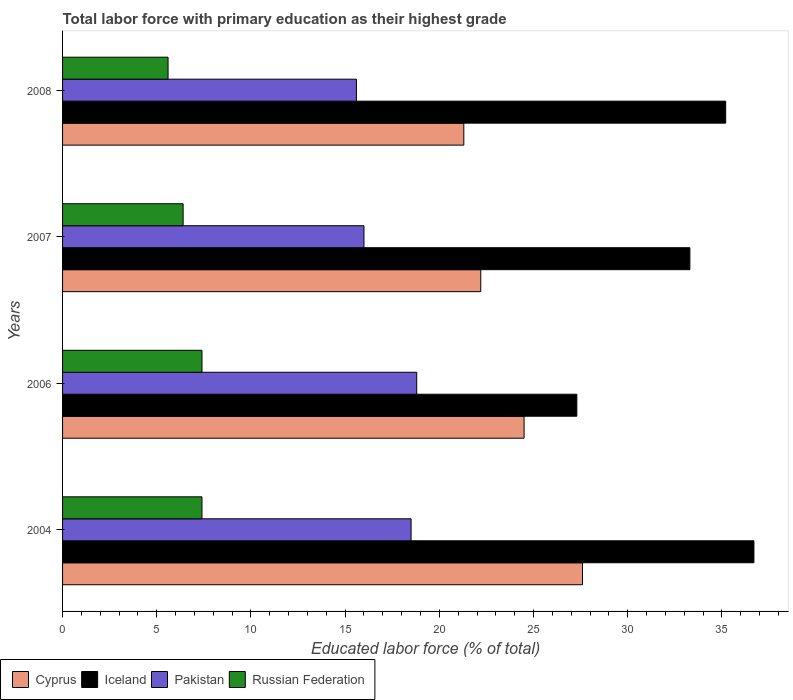How many groups of bars are there?
Your answer should be very brief. 4. Are the number of bars per tick equal to the number of legend labels?
Provide a short and direct response. Yes. Are the number of bars on each tick of the Y-axis equal?
Keep it short and to the point. Yes. What is the label of the 2nd group of bars from the top?
Give a very brief answer. 2007. What is the percentage of total labor force with primary education in Pakistan in 2007?
Make the answer very short. 16. Across all years, what is the maximum percentage of total labor force with primary education in Iceland?
Provide a succinct answer. 36.7. Across all years, what is the minimum percentage of total labor force with primary education in Cyprus?
Provide a succinct answer. 21.3. In which year was the percentage of total labor force with primary education in Cyprus maximum?
Provide a short and direct response. 2004. In which year was the percentage of total labor force with primary education in Cyprus minimum?
Give a very brief answer. 2008. What is the total percentage of total labor force with primary education in Pakistan in the graph?
Your answer should be very brief. 68.9. What is the difference between the percentage of total labor force with primary education in Russian Federation in 2004 and that in 2006?
Make the answer very short. 0. What is the difference between the percentage of total labor force with primary education in Pakistan in 2004 and the percentage of total labor force with primary education in Russian Federation in 2007?
Ensure brevity in your answer.  12.1. What is the average percentage of total labor force with primary education in Pakistan per year?
Offer a very short reply. 17.22. In the year 2007, what is the difference between the percentage of total labor force with primary education in Cyprus and percentage of total labor force with primary education in Russian Federation?
Offer a terse response. 15.8. What is the ratio of the percentage of total labor force with primary education in Pakistan in 2004 to that in 2006?
Offer a very short reply. 0.98. What is the difference between the highest and the second highest percentage of total labor force with primary education in Cyprus?
Offer a very short reply. 3.1. What is the difference between the highest and the lowest percentage of total labor force with primary education in Cyprus?
Your response must be concise. 6.3. What does the 4th bar from the top in 2007 represents?
Make the answer very short. Cyprus. What does the 4th bar from the bottom in 2007 represents?
Provide a succinct answer. Russian Federation. Is it the case that in every year, the sum of the percentage of total labor force with primary education in Iceland and percentage of total labor force with primary education in Russian Federation is greater than the percentage of total labor force with primary education in Cyprus?
Make the answer very short. Yes. How many bars are there?
Make the answer very short. 16. Are all the bars in the graph horizontal?
Keep it short and to the point. Yes. What is the difference between two consecutive major ticks on the X-axis?
Keep it short and to the point. 5. How many legend labels are there?
Give a very brief answer. 4. What is the title of the graph?
Your response must be concise. Total labor force with primary education as their highest grade. Does "Luxembourg" appear as one of the legend labels in the graph?
Give a very brief answer. No. What is the label or title of the X-axis?
Your answer should be very brief. Educated labor force (% of total). What is the label or title of the Y-axis?
Make the answer very short. Years. What is the Educated labor force (% of total) of Cyprus in 2004?
Give a very brief answer. 27.6. What is the Educated labor force (% of total) in Iceland in 2004?
Offer a very short reply. 36.7. What is the Educated labor force (% of total) of Pakistan in 2004?
Your response must be concise. 18.5. What is the Educated labor force (% of total) in Russian Federation in 2004?
Your response must be concise. 7.4. What is the Educated labor force (% of total) in Iceland in 2006?
Offer a terse response. 27.3. What is the Educated labor force (% of total) in Pakistan in 2006?
Your response must be concise. 18.8. What is the Educated labor force (% of total) in Russian Federation in 2006?
Provide a short and direct response. 7.4. What is the Educated labor force (% of total) of Cyprus in 2007?
Make the answer very short. 22.2. What is the Educated labor force (% of total) in Iceland in 2007?
Your response must be concise. 33.3. What is the Educated labor force (% of total) in Russian Federation in 2007?
Offer a terse response. 6.4. What is the Educated labor force (% of total) in Cyprus in 2008?
Make the answer very short. 21.3. What is the Educated labor force (% of total) in Iceland in 2008?
Offer a very short reply. 35.2. What is the Educated labor force (% of total) of Pakistan in 2008?
Offer a very short reply. 15.6. What is the Educated labor force (% of total) of Russian Federation in 2008?
Give a very brief answer. 5.6. Across all years, what is the maximum Educated labor force (% of total) in Cyprus?
Ensure brevity in your answer.  27.6. Across all years, what is the maximum Educated labor force (% of total) in Iceland?
Provide a succinct answer. 36.7. Across all years, what is the maximum Educated labor force (% of total) in Pakistan?
Your answer should be very brief. 18.8. Across all years, what is the maximum Educated labor force (% of total) in Russian Federation?
Provide a succinct answer. 7.4. Across all years, what is the minimum Educated labor force (% of total) in Cyprus?
Keep it short and to the point. 21.3. Across all years, what is the minimum Educated labor force (% of total) of Iceland?
Offer a terse response. 27.3. Across all years, what is the minimum Educated labor force (% of total) of Pakistan?
Keep it short and to the point. 15.6. Across all years, what is the minimum Educated labor force (% of total) of Russian Federation?
Ensure brevity in your answer.  5.6. What is the total Educated labor force (% of total) in Cyprus in the graph?
Make the answer very short. 95.6. What is the total Educated labor force (% of total) of Iceland in the graph?
Keep it short and to the point. 132.5. What is the total Educated labor force (% of total) in Pakistan in the graph?
Provide a succinct answer. 68.9. What is the total Educated labor force (% of total) of Russian Federation in the graph?
Provide a succinct answer. 26.8. What is the difference between the Educated labor force (% of total) of Cyprus in 2004 and that in 2006?
Give a very brief answer. 3.1. What is the difference between the Educated labor force (% of total) of Russian Federation in 2004 and that in 2006?
Your response must be concise. 0. What is the difference between the Educated labor force (% of total) of Cyprus in 2004 and that in 2007?
Offer a terse response. 5.4. What is the difference between the Educated labor force (% of total) of Pakistan in 2004 and that in 2007?
Provide a succinct answer. 2.5. What is the difference between the Educated labor force (% of total) of Cyprus in 2004 and that in 2008?
Your response must be concise. 6.3. What is the difference between the Educated labor force (% of total) in Iceland in 2004 and that in 2008?
Offer a terse response. 1.5. What is the difference between the Educated labor force (% of total) in Russian Federation in 2004 and that in 2008?
Make the answer very short. 1.8. What is the difference between the Educated labor force (% of total) in Cyprus in 2006 and that in 2007?
Your answer should be very brief. 2.3. What is the difference between the Educated labor force (% of total) in Pakistan in 2006 and that in 2007?
Provide a short and direct response. 2.8. What is the difference between the Educated labor force (% of total) in Russian Federation in 2006 and that in 2007?
Ensure brevity in your answer.  1. What is the difference between the Educated labor force (% of total) of Iceland in 2006 and that in 2008?
Offer a terse response. -7.9. What is the difference between the Educated labor force (% of total) in Pakistan in 2006 and that in 2008?
Give a very brief answer. 3.2. What is the difference between the Educated labor force (% of total) of Cyprus in 2007 and that in 2008?
Your response must be concise. 0.9. What is the difference between the Educated labor force (% of total) of Iceland in 2007 and that in 2008?
Ensure brevity in your answer.  -1.9. What is the difference between the Educated labor force (% of total) of Russian Federation in 2007 and that in 2008?
Give a very brief answer. 0.8. What is the difference between the Educated labor force (% of total) in Cyprus in 2004 and the Educated labor force (% of total) in Pakistan in 2006?
Your answer should be compact. 8.8. What is the difference between the Educated labor force (% of total) in Cyprus in 2004 and the Educated labor force (% of total) in Russian Federation in 2006?
Offer a very short reply. 20.2. What is the difference between the Educated labor force (% of total) in Iceland in 2004 and the Educated labor force (% of total) in Pakistan in 2006?
Provide a short and direct response. 17.9. What is the difference between the Educated labor force (% of total) of Iceland in 2004 and the Educated labor force (% of total) of Russian Federation in 2006?
Offer a very short reply. 29.3. What is the difference between the Educated labor force (% of total) in Pakistan in 2004 and the Educated labor force (% of total) in Russian Federation in 2006?
Your response must be concise. 11.1. What is the difference between the Educated labor force (% of total) of Cyprus in 2004 and the Educated labor force (% of total) of Russian Federation in 2007?
Offer a terse response. 21.2. What is the difference between the Educated labor force (% of total) of Iceland in 2004 and the Educated labor force (% of total) of Pakistan in 2007?
Your answer should be very brief. 20.7. What is the difference between the Educated labor force (% of total) in Iceland in 2004 and the Educated labor force (% of total) in Russian Federation in 2007?
Ensure brevity in your answer.  30.3. What is the difference between the Educated labor force (% of total) of Cyprus in 2004 and the Educated labor force (% of total) of Iceland in 2008?
Ensure brevity in your answer.  -7.6. What is the difference between the Educated labor force (% of total) of Cyprus in 2004 and the Educated labor force (% of total) of Russian Federation in 2008?
Keep it short and to the point. 22. What is the difference between the Educated labor force (% of total) of Iceland in 2004 and the Educated labor force (% of total) of Pakistan in 2008?
Provide a short and direct response. 21.1. What is the difference between the Educated labor force (% of total) in Iceland in 2004 and the Educated labor force (% of total) in Russian Federation in 2008?
Offer a very short reply. 31.1. What is the difference between the Educated labor force (% of total) in Cyprus in 2006 and the Educated labor force (% of total) in Iceland in 2007?
Offer a very short reply. -8.8. What is the difference between the Educated labor force (% of total) of Cyprus in 2006 and the Educated labor force (% of total) of Pakistan in 2007?
Your answer should be very brief. 8.5. What is the difference between the Educated labor force (% of total) of Cyprus in 2006 and the Educated labor force (% of total) of Russian Federation in 2007?
Give a very brief answer. 18.1. What is the difference between the Educated labor force (% of total) of Iceland in 2006 and the Educated labor force (% of total) of Russian Federation in 2007?
Provide a short and direct response. 20.9. What is the difference between the Educated labor force (% of total) in Cyprus in 2006 and the Educated labor force (% of total) in Iceland in 2008?
Give a very brief answer. -10.7. What is the difference between the Educated labor force (% of total) in Cyprus in 2006 and the Educated labor force (% of total) in Pakistan in 2008?
Provide a succinct answer. 8.9. What is the difference between the Educated labor force (% of total) in Cyprus in 2006 and the Educated labor force (% of total) in Russian Federation in 2008?
Ensure brevity in your answer.  18.9. What is the difference between the Educated labor force (% of total) in Iceland in 2006 and the Educated labor force (% of total) in Pakistan in 2008?
Your answer should be very brief. 11.7. What is the difference between the Educated labor force (% of total) of Iceland in 2006 and the Educated labor force (% of total) of Russian Federation in 2008?
Offer a terse response. 21.7. What is the difference between the Educated labor force (% of total) in Cyprus in 2007 and the Educated labor force (% of total) in Pakistan in 2008?
Offer a very short reply. 6.6. What is the difference between the Educated labor force (% of total) in Iceland in 2007 and the Educated labor force (% of total) in Russian Federation in 2008?
Offer a very short reply. 27.7. What is the average Educated labor force (% of total) of Cyprus per year?
Offer a very short reply. 23.9. What is the average Educated labor force (% of total) in Iceland per year?
Provide a short and direct response. 33.12. What is the average Educated labor force (% of total) of Pakistan per year?
Provide a succinct answer. 17.23. What is the average Educated labor force (% of total) of Russian Federation per year?
Your answer should be very brief. 6.7. In the year 2004, what is the difference between the Educated labor force (% of total) of Cyprus and Educated labor force (% of total) of Russian Federation?
Provide a succinct answer. 20.2. In the year 2004, what is the difference between the Educated labor force (% of total) in Iceland and Educated labor force (% of total) in Pakistan?
Your answer should be very brief. 18.2. In the year 2004, what is the difference between the Educated labor force (% of total) in Iceland and Educated labor force (% of total) in Russian Federation?
Provide a short and direct response. 29.3. In the year 2006, what is the difference between the Educated labor force (% of total) in Cyprus and Educated labor force (% of total) in Pakistan?
Offer a very short reply. 5.7. In the year 2006, what is the difference between the Educated labor force (% of total) in Iceland and Educated labor force (% of total) in Russian Federation?
Offer a very short reply. 19.9. In the year 2007, what is the difference between the Educated labor force (% of total) of Cyprus and Educated labor force (% of total) of Iceland?
Provide a succinct answer. -11.1. In the year 2007, what is the difference between the Educated labor force (% of total) of Iceland and Educated labor force (% of total) of Pakistan?
Offer a terse response. 17.3. In the year 2007, what is the difference between the Educated labor force (% of total) in Iceland and Educated labor force (% of total) in Russian Federation?
Provide a succinct answer. 26.9. In the year 2007, what is the difference between the Educated labor force (% of total) in Pakistan and Educated labor force (% of total) in Russian Federation?
Give a very brief answer. 9.6. In the year 2008, what is the difference between the Educated labor force (% of total) in Iceland and Educated labor force (% of total) in Pakistan?
Keep it short and to the point. 19.6. In the year 2008, what is the difference between the Educated labor force (% of total) of Iceland and Educated labor force (% of total) of Russian Federation?
Make the answer very short. 29.6. In the year 2008, what is the difference between the Educated labor force (% of total) in Pakistan and Educated labor force (% of total) in Russian Federation?
Your answer should be very brief. 10. What is the ratio of the Educated labor force (% of total) in Cyprus in 2004 to that in 2006?
Keep it short and to the point. 1.13. What is the ratio of the Educated labor force (% of total) of Iceland in 2004 to that in 2006?
Your answer should be compact. 1.34. What is the ratio of the Educated labor force (% of total) of Pakistan in 2004 to that in 2006?
Your answer should be compact. 0.98. What is the ratio of the Educated labor force (% of total) of Russian Federation in 2004 to that in 2006?
Provide a succinct answer. 1. What is the ratio of the Educated labor force (% of total) of Cyprus in 2004 to that in 2007?
Offer a terse response. 1.24. What is the ratio of the Educated labor force (% of total) in Iceland in 2004 to that in 2007?
Provide a short and direct response. 1.1. What is the ratio of the Educated labor force (% of total) of Pakistan in 2004 to that in 2007?
Offer a very short reply. 1.16. What is the ratio of the Educated labor force (% of total) of Russian Federation in 2004 to that in 2007?
Provide a succinct answer. 1.16. What is the ratio of the Educated labor force (% of total) in Cyprus in 2004 to that in 2008?
Your answer should be compact. 1.3. What is the ratio of the Educated labor force (% of total) in Iceland in 2004 to that in 2008?
Your answer should be compact. 1.04. What is the ratio of the Educated labor force (% of total) in Pakistan in 2004 to that in 2008?
Offer a terse response. 1.19. What is the ratio of the Educated labor force (% of total) in Russian Federation in 2004 to that in 2008?
Ensure brevity in your answer.  1.32. What is the ratio of the Educated labor force (% of total) of Cyprus in 2006 to that in 2007?
Your answer should be compact. 1.1. What is the ratio of the Educated labor force (% of total) in Iceland in 2006 to that in 2007?
Ensure brevity in your answer.  0.82. What is the ratio of the Educated labor force (% of total) in Pakistan in 2006 to that in 2007?
Ensure brevity in your answer.  1.18. What is the ratio of the Educated labor force (% of total) in Russian Federation in 2006 to that in 2007?
Provide a short and direct response. 1.16. What is the ratio of the Educated labor force (% of total) of Cyprus in 2006 to that in 2008?
Give a very brief answer. 1.15. What is the ratio of the Educated labor force (% of total) of Iceland in 2006 to that in 2008?
Provide a short and direct response. 0.78. What is the ratio of the Educated labor force (% of total) in Pakistan in 2006 to that in 2008?
Offer a terse response. 1.21. What is the ratio of the Educated labor force (% of total) of Russian Federation in 2006 to that in 2008?
Provide a short and direct response. 1.32. What is the ratio of the Educated labor force (% of total) of Cyprus in 2007 to that in 2008?
Provide a succinct answer. 1.04. What is the ratio of the Educated labor force (% of total) in Iceland in 2007 to that in 2008?
Give a very brief answer. 0.95. What is the ratio of the Educated labor force (% of total) of Pakistan in 2007 to that in 2008?
Your answer should be compact. 1.03. What is the difference between the highest and the second highest Educated labor force (% of total) of Pakistan?
Your answer should be compact. 0.3. What is the difference between the highest and the second highest Educated labor force (% of total) of Russian Federation?
Keep it short and to the point. 0. What is the difference between the highest and the lowest Educated labor force (% of total) of Cyprus?
Make the answer very short. 6.3. What is the difference between the highest and the lowest Educated labor force (% of total) of Pakistan?
Provide a short and direct response. 3.2. 